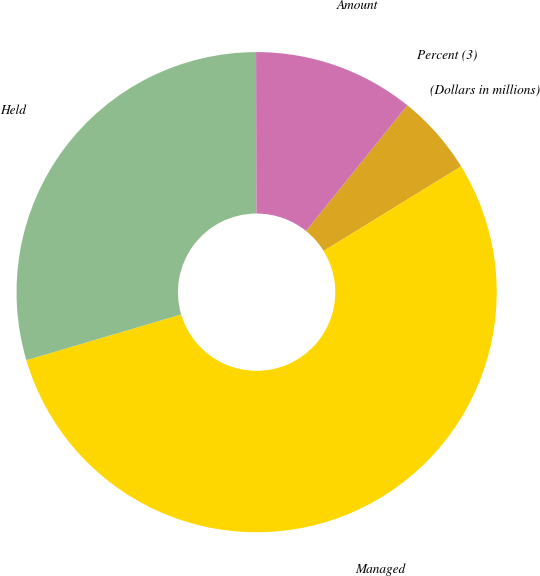Convert chart. <chart><loc_0><loc_0><loc_500><loc_500><pie_chart><fcel>(Dollars in millions)<fcel>Managed<fcel>Held<fcel>Amount<fcel>Percent (3)<nl><fcel>5.42%<fcel>54.2%<fcel>29.53%<fcel>10.84%<fcel>0.0%<nl></chart> 